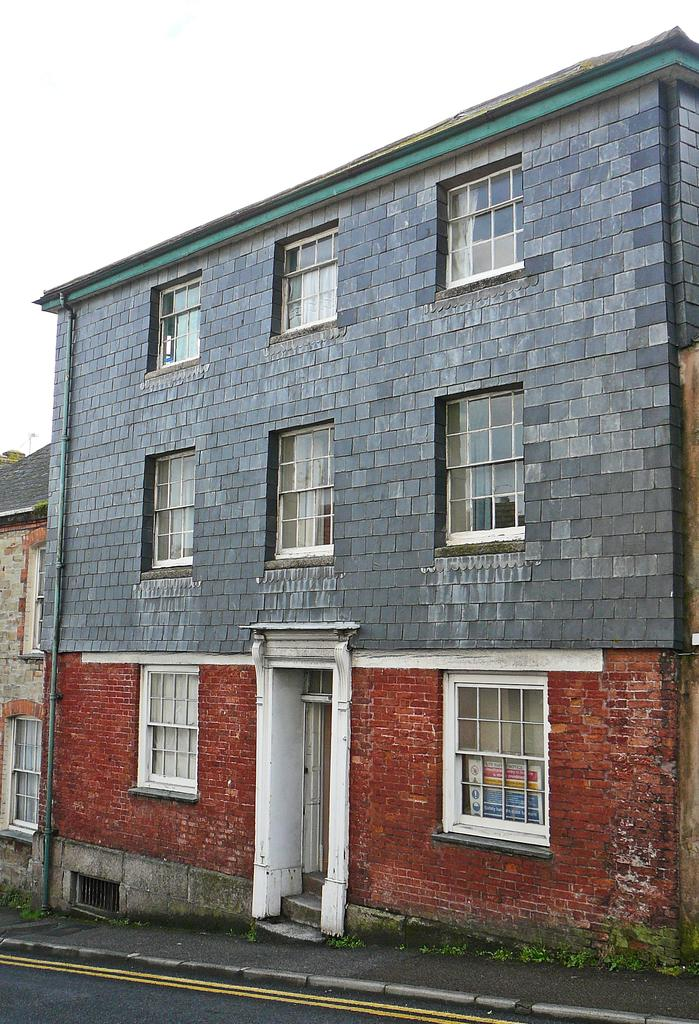What is the main structure in the center of the image? There is a building in the center of the image. What can be seen on the left side of the image? There is a house on the left side of the image. What type of vegetation is visible in the image? There are plants visible in the image. What is at the bottom side of the image? There is a road at the bottom side of the image. What is visible in the background of the image? The sky is visible in the background of the image. What type of skin condition can be seen on the stranger in the image? There is no stranger present in the image, so it is not possible to determine if they have any skin condition. Can you tell me how many arches are visible in the image? There is no mention of arches in the provided facts, so it is not possible to determine if any are visible in the image. 